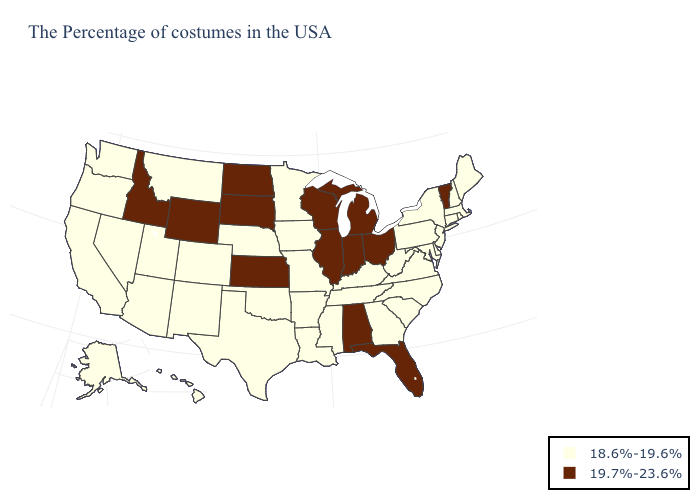Does Pennsylvania have the highest value in the USA?
Be succinct. No. Name the states that have a value in the range 19.7%-23.6%?
Short answer required. Vermont, Ohio, Florida, Michigan, Indiana, Alabama, Wisconsin, Illinois, Kansas, South Dakota, North Dakota, Wyoming, Idaho. Name the states that have a value in the range 19.7%-23.6%?
Give a very brief answer. Vermont, Ohio, Florida, Michigan, Indiana, Alabama, Wisconsin, Illinois, Kansas, South Dakota, North Dakota, Wyoming, Idaho. Name the states that have a value in the range 19.7%-23.6%?
Concise answer only. Vermont, Ohio, Florida, Michigan, Indiana, Alabama, Wisconsin, Illinois, Kansas, South Dakota, North Dakota, Wyoming, Idaho. Name the states that have a value in the range 19.7%-23.6%?
Keep it brief. Vermont, Ohio, Florida, Michigan, Indiana, Alabama, Wisconsin, Illinois, Kansas, South Dakota, North Dakota, Wyoming, Idaho. What is the highest value in states that border Wyoming?
Answer briefly. 19.7%-23.6%. Which states have the highest value in the USA?
Answer briefly. Vermont, Ohio, Florida, Michigan, Indiana, Alabama, Wisconsin, Illinois, Kansas, South Dakota, North Dakota, Wyoming, Idaho. What is the value of Hawaii?
Short answer required. 18.6%-19.6%. Name the states that have a value in the range 19.7%-23.6%?
Give a very brief answer. Vermont, Ohio, Florida, Michigan, Indiana, Alabama, Wisconsin, Illinois, Kansas, South Dakota, North Dakota, Wyoming, Idaho. Name the states that have a value in the range 18.6%-19.6%?
Answer briefly. Maine, Massachusetts, Rhode Island, New Hampshire, Connecticut, New York, New Jersey, Delaware, Maryland, Pennsylvania, Virginia, North Carolina, South Carolina, West Virginia, Georgia, Kentucky, Tennessee, Mississippi, Louisiana, Missouri, Arkansas, Minnesota, Iowa, Nebraska, Oklahoma, Texas, Colorado, New Mexico, Utah, Montana, Arizona, Nevada, California, Washington, Oregon, Alaska, Hawaii. Does Minnesota have the lowest value in the MidWest?
Quick response, please. Yes. What is the value of Utah?
Be succinct. 18.6%-19.6%. Among the states that border Indiana , which have the highest value?
Answer briefly. Ohio, Michigan, Illinois. 